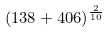Convert formula to latex. <formula><loc_0><loc_0><loc_500><loc_500>( 1 3 8 + 4 0 6 ) ^ { \frac { 2 } { 1 0 } }</formula> 